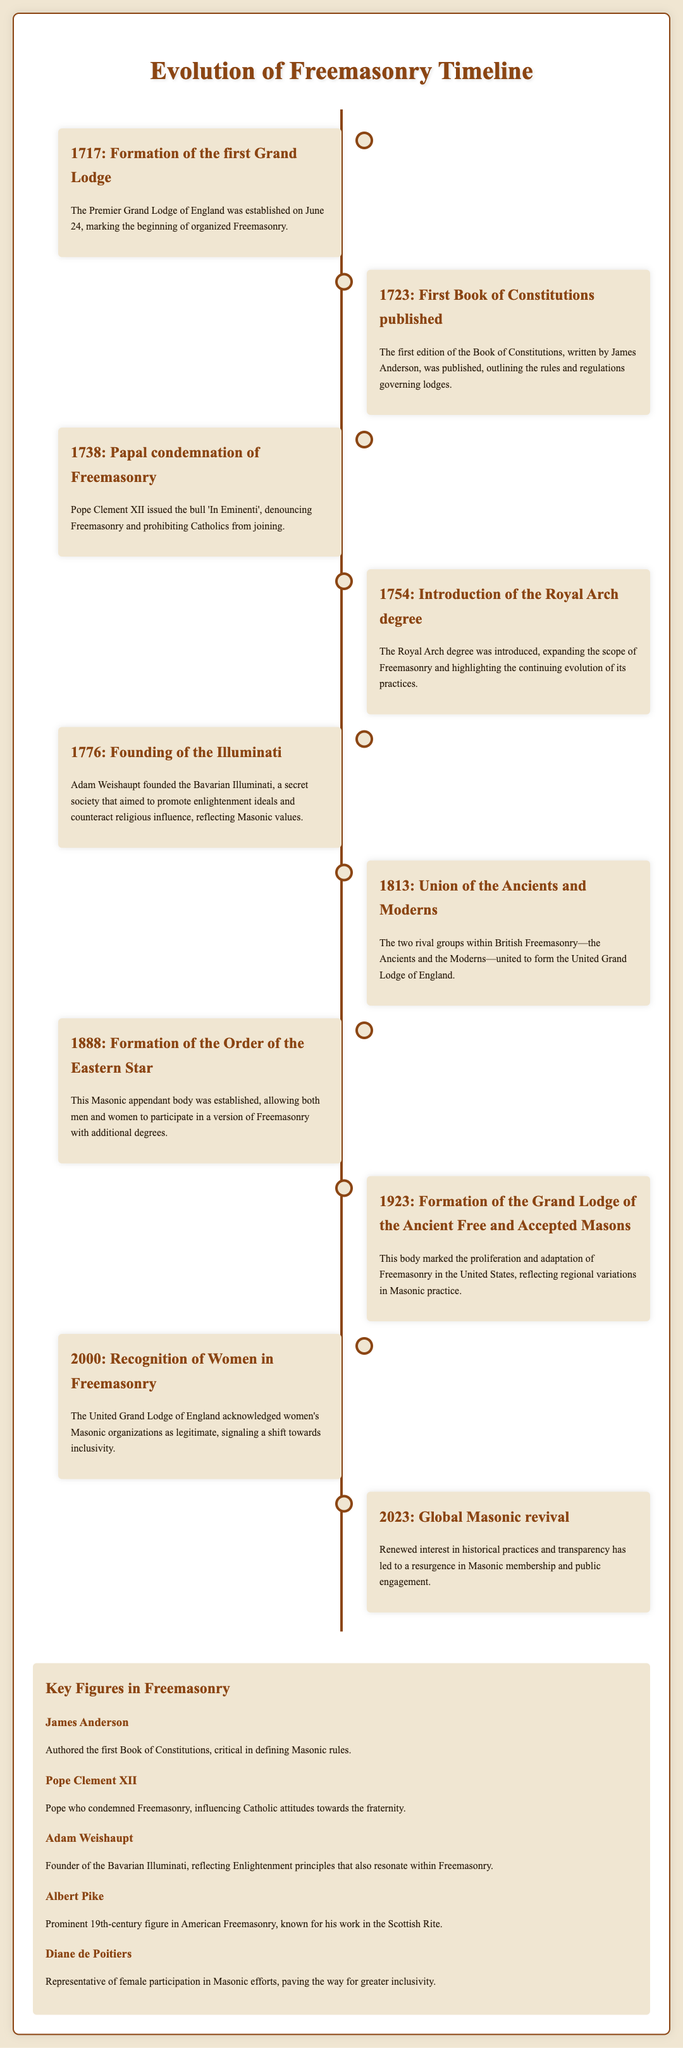What year was the first Grand Lodge formed? The timeline states that the first Grand Lodge was formed in 1717.
Answer: 1717 Who authored the first Book of Constitutions? The document indicates that the first Book of Constitutions was written by James Anderson.
Answer: James Anderson What significant event occurred in 1738? The timeline notes that Pope Clement XII issued a papal condemnation of Freemasonry in 1738.
Answer: Papal condemnation What degree was introduced in 1754? According to the timeline, the Royal Arch degree was introduced in 1754.
Answer: Royal Arch degree In what year did the United Grand Lodge of England form? The document states that the Union of the Ancients and Moderns occurred in 1813, forming the United Grand Lodge of England.
Answer: 1813 Which organization allowed both men and women to participate in Freemasonry? The timeline mentions the formation of the Order of the Eastern Star in 1888, which allowed both genders to take part.
Answer: Order of the Eastern Star What was significant about the year 2000 for Freemasonry? The document highlights that in 2000, the United Grand Lodge of England recognized women's Masonic organizations as legitimate.
Answer: Recognition of Women Who founded the Bavarian Illuminati? The timeline attributes the founding of the Bavarian Illuminati to Adam Weishaupt.
Answer: Adam Weishaupt Which key figure is associated with the Scottish Rite? The document states that Albert Pike is known for his work in the Scottish Rite in 19th-century American Freemasonry.
Answer: Albert Pike 